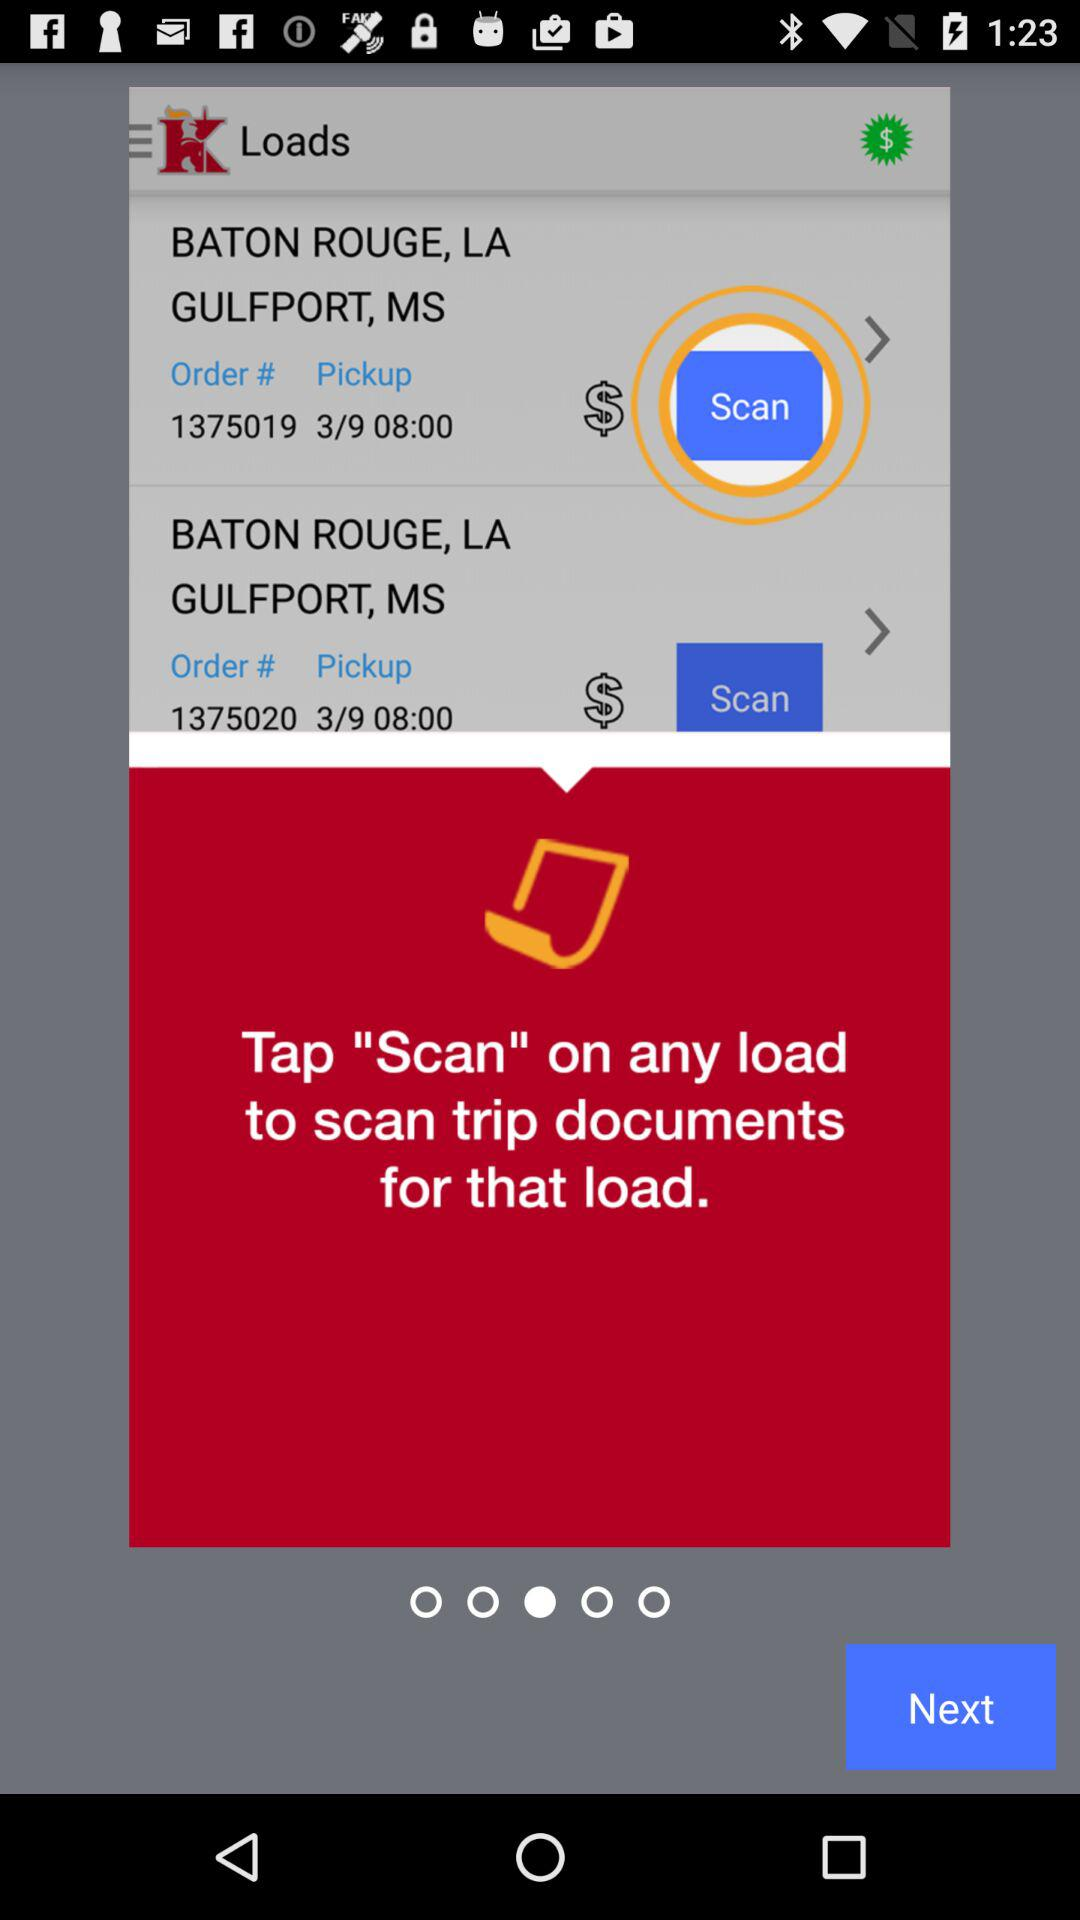How many loads are there?
Answer the question using a single word or phrase. 2 